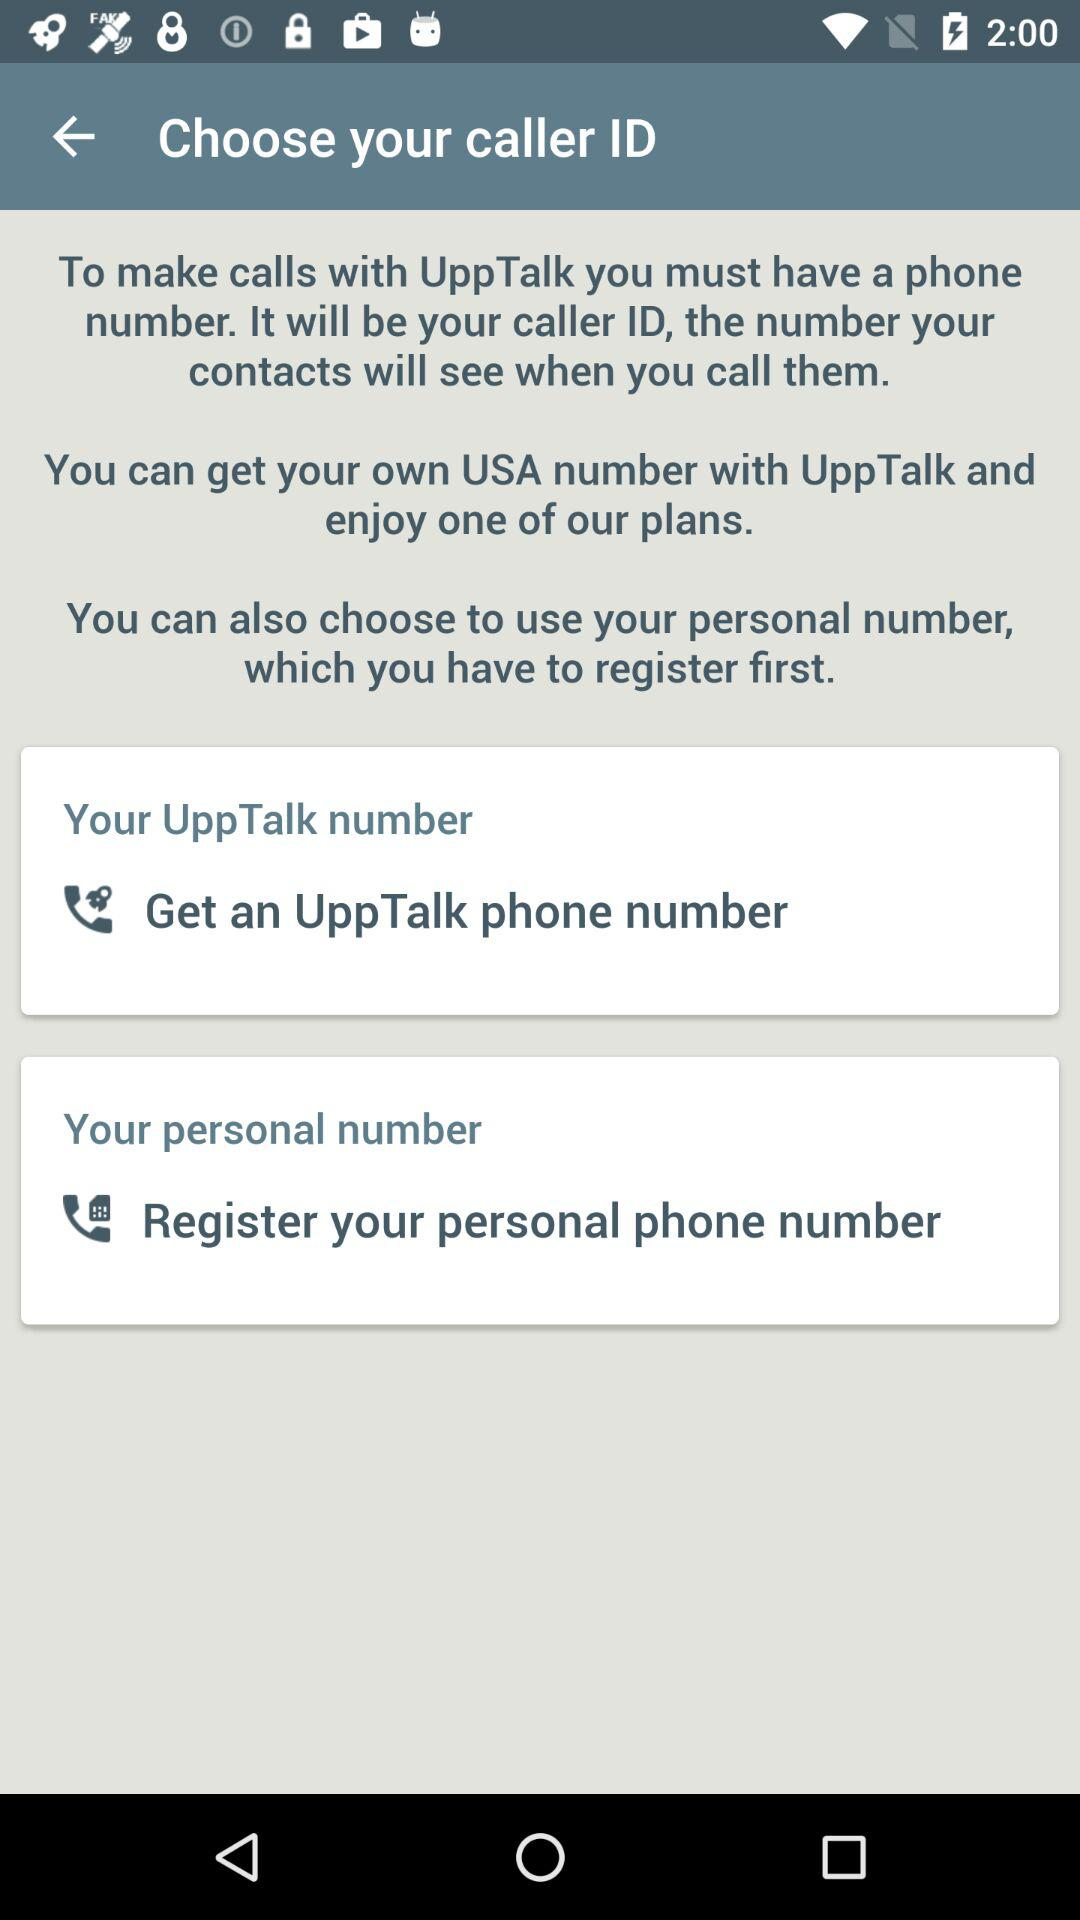Which "UppTalk" phone number was received?
When the provided information is insufficient, respond with <no answer>. <no answer> 